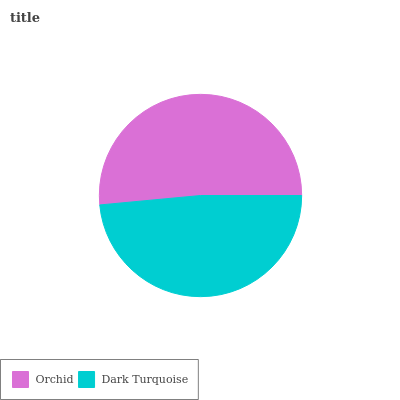Is Dark Turquoise the minimum?
Answer yes or no. Yes. Is Orchid the maximum?
Answer yes or no. Yes. Is Dark Turquoise the maximum?
Answer yes or no. No. Is Orchid greater than Dark Turquoise?
Answer yes or no. Yes. Is Dark Turquoise less than Orchid?
Answer yes or no. Yes. Is Dark Turquoise greater than Orchid?
Answer yes or no. No. Is Orchid less than Dark Turquoise?
Answer yes or no. No. Is Orchid the high median?
Answer yes or no. Yes. Is Dark Turquoise the low median?
Answer yes or no. Yes. Is Dark Turquoise the high median?
Answer yes or no. No. Is Orchid the low median?
Answer yes or no. No. 